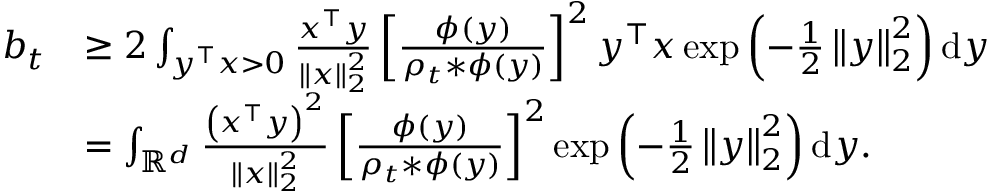Convert formula to latex. <formula><loc_0><loc_0><loc_500><loc_500>\begin{array} { r l } { b _ { t } } & { \geq 2 \int _ { y ^ { \top } x > 0 } \frac { x ^ { \top } y } { \left \| x \right \| _ { 2 } ^ { 2 } } \left [ \frac { \phi \left ( y \right ) } { \rho _ { t } * \phi \left ( y \right ) } \right ] ^ { 2 } y ^ { \top } x \exp \left ( - \frac { 1 } { 2 } \left \| y \right \| _ { 2 } ^ { 2 } \right ) d y } \\ & { = \int _ { \mathbb { R } ^ { d } } \frac { \left ( x ^ { \top } y \right ) ^ { 2 } } { \left \| x \right \| _ { 2 } ^ { 2 } } \left [ \frac { \phi \left ( y \right ) } { \rho _ { t } * \phi \left ( y \right ) } \right ] ^ { 2 } \exp \left ( - \frac { 1 } { 2 } \left \| y \right \| _ { 2 } ^ { 2 } \right ) d y . } \end{array}</formula> 